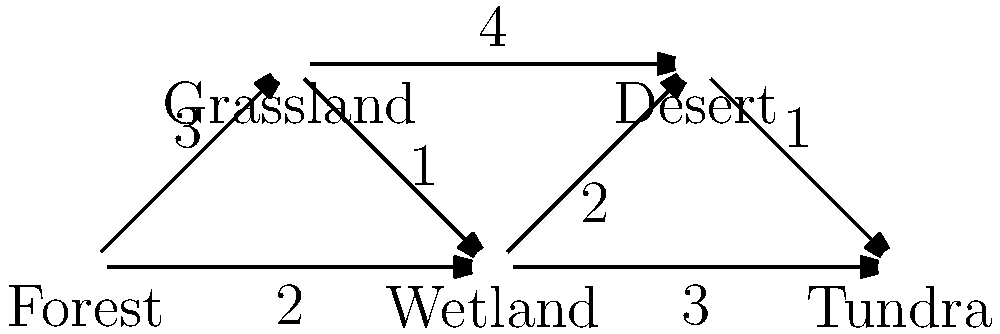A group of migratory birds is planning their annual journey across five different ecosystems: Forest, Grassland, Wetland, Desert, and Tundra. The graph represents the possible migration routes between these ecosystems, with the numbers indicating the energy cost (in arbitrary units) for traveling between them. What is the optimal path for the birds to migrate from the Forest to the Tundra while minimizing their total energy expenditure? To find the optimal path with minimal energy expenditure, we can use Dijkstra's algorithm:

1. Initialize:
   - Set Forest as the starting node with distance 0
   - Set all other nodes to infinity
   - Mark all nodes as unvisited

2. For the current node (starting with Forest), consider all unvisited neighbors and calculate their tentative distances:
   - Forest to Grassland: 0 + 3 = 3
   - Forest to Wetland: 0 + 2 = 2

3. Mark Forest as visited. Wetland now has the smallest tentative distance (2), so it becomes the current node.

4. Update neighbors of Wetland:
   - Wetland to Grassland: 2 + 1 = 3 (no change)
   - Wetland to Desert: 2 + 2 = 4
   - Wetland to Tundra: 2 + 3 = 5

5. Mark Wetland as visited. Grassland has the smallest tentative distance (3), so it becomes the current node.

6. Update neighbors of Grassland:
   - Grassland to Desert: 3 + 4 = 7 (no improvement)

7. Mark Grassland as visited. Desert has the smallest tentative distance (4), so it becomes the current node.

8. Update neighbors of Desert:
   - Desert to Tundra: 4 + 1 = 5 (no improvement)

9. Mark Desert as visited. Tundra is the only unvisited node left with a distance of 5.

The optimal path is Forest → Wetland → Tundra, with a total energy cost of 5 units.
Answer: Forest → Wetland → Tundra 